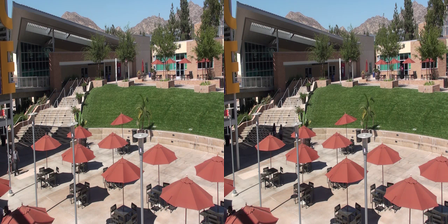You are provided with an image which contains two pictures side by side. Your task is to identify the differences between the two pictures. Separate the differences with a comma. Upon close examination, the differences between the two pictures are as follows: the left side has one less table on the patio area, the right side has an extra tree on the mountain range, the left side is missing a window on the building, the right side has an additional red stripe on one umbrella, the left side shows a missing segment on the handrail of the staircase, the right side has a person walking on the stairs which is not present on the left, the left side includes a shadow on the building not seen on the right, the right side has a bird in the sky absent on the left. 